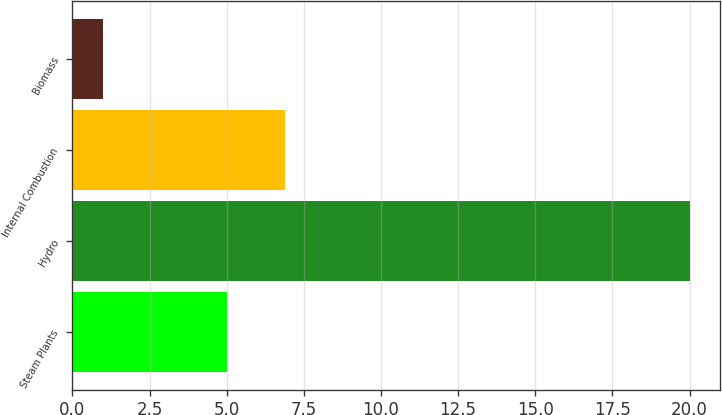Convert chart to OTSL. <chart><loc_0><loc_0><loc_500><loc_500><bar_chart><fcel>Steam Plants<fcel>Hydro<fcel>Internal Combustion<fcel>Biomass<nl><fcel>5<fcel>20<fcel>6.9<fcel>1<nl></chart> 